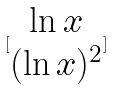Convert formula to latex. <formula><loc_0><loc_0><loc_500><loc_500>[ \begin{matrix} \ln x \\ ( \ln x ) ^ { 2 } \end{matrix} ]</formula> 